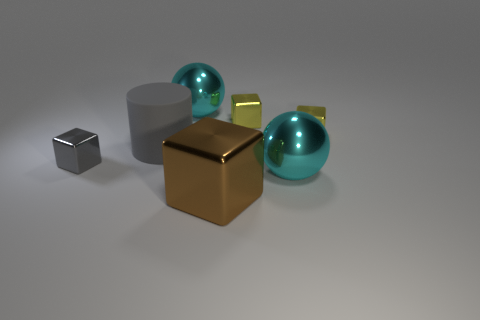Subtract all gray blocks. How many blocks are left? 3 Subtract all balls. How many objects are left? 5 Subtract 2 blocks. How many blocks are left? 2 Subtract all blue cylinders. Subtract all purple balls. How many cylinders are left? 1 Subtract all blue cylinders. How many gray balls are left? 0 Subtract all large brown matte blocks. Subtract all big metal blocks. How many objects are left? 6 Add 3 metal blocks. How many metal blocks are left? 7 Add 4 small brown metallic blocks. How many small brown metallic blocks exist? 4 Add 1 big red cylinders. How many objects exist? 8 Subtract all yellow blocks. How many blocks are left? 2 